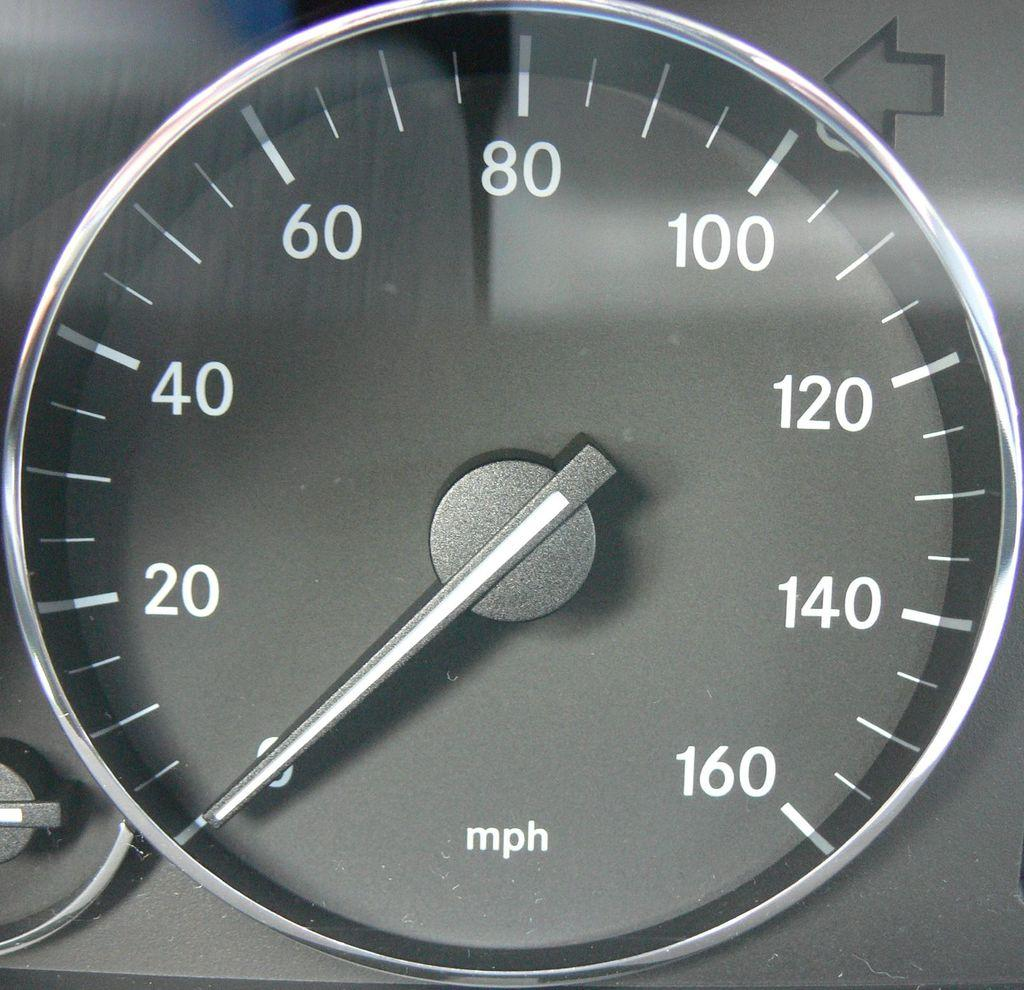What type of instrument is visible in the image? There is a speedometer in the image. What can be used to indicate direction in the image? There is a direction symbol in the image. Can you describe any other objects present in the image? There are some unspecified objects in the image. What type of treatment is being administered to the bushes in the image? There are no bushes present in the image, so no treatment can be administered to them. What is the cause of the thunder in the image? There is no thunder present in the image. 